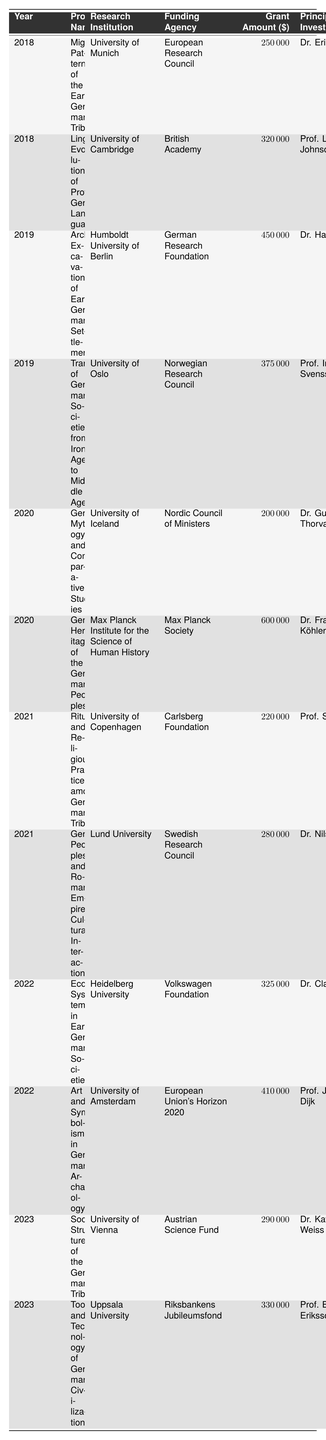What is the total grant amount received for projects in 2019? From the table, the projects for 2019 are "Archaeological Excavations of Early Germanic Settlements" with a grant amount of 450000 and "Transformation of Germanic Societies from Iron Age to Middle Ages" with a grant amount of 375000. Summing these amounts gives 450000 + 375000 = 825000.
Answer: 825000 Which project received the highest grant amount? The grant amounts for the projects are as follows: 250000 (2018), 320000 (2018), 450000 (2019), 375000 (2019), 200000 (2020), 600000 (2020), 220000 (2021), 280000 (2021), 325000 (2022), 410000 (2022), 290000 (2023), and 330000 (2023). The highest amount is 600000 for the project "Genetic Heritage of the Germanic Peoples" in 2020.
Answer: Genetic Heritage of the Germanic Peoples Which funding agency provided grants for projects in 2022? The projects for 2022 are "Economic Systems in Early Germanic Societies" by the Volkswagen Foundation and "Art and Symbolism in Germanic Archaeology" by the European Union's Horizon 2020. Thus, the funding agencies are Volkswagen Foundation and European Union's Horizon 2020.
Answer: Volkswagen Foundation, European Union's Horizon 2020 Did any projects receive grants from the British Academy? The project "Linguistic Evolution of Proto-Germanic Languages" in 2018 received a grant from the British Academy. Therefore, it is true that at least one project received a grant from the British Academy.
Answer: Yes What is the average grant amount for the projects from 2021? The grant amounts for the two projects in 2021 are 220000 and 280000. The sum of these amounts is 220000 + 280000 = 500000. Since there are two projects, the average is 500000 / 2 = 250000.
Answer: 250000 How many different research institutions received grants in 2020? The projects in 2020 are "Germanic Mythology and Comparative Studies" by the University of Iceland and "Genetic Heritage of the Germanic Peoples" by the Max Planck Institute for the Science of Human History. Therefore, there are two different institutions that received grants in 2020.
Answer: 2 Which year had the maximum number of projects listed? Analyzing the data, there are 2 projects listed for 2018, 2 for 2019, 2 for 2020, 2 for 2021, 2 for 2022, and 2 for 2023. Since all years have the same number of projects (2), no one year stands out with more.
Answer: None, all years are equal What is the total grant amount for all projects funded by the European Union’s Horizon 2020? The only project funded by the European Union’s Horizon 2020 is "Art and Symbolism in Germanic Archaeology" with a grant of 410000 in 2022. Thus, the total grant amount from this agency is 410000.
Answer: 410000 